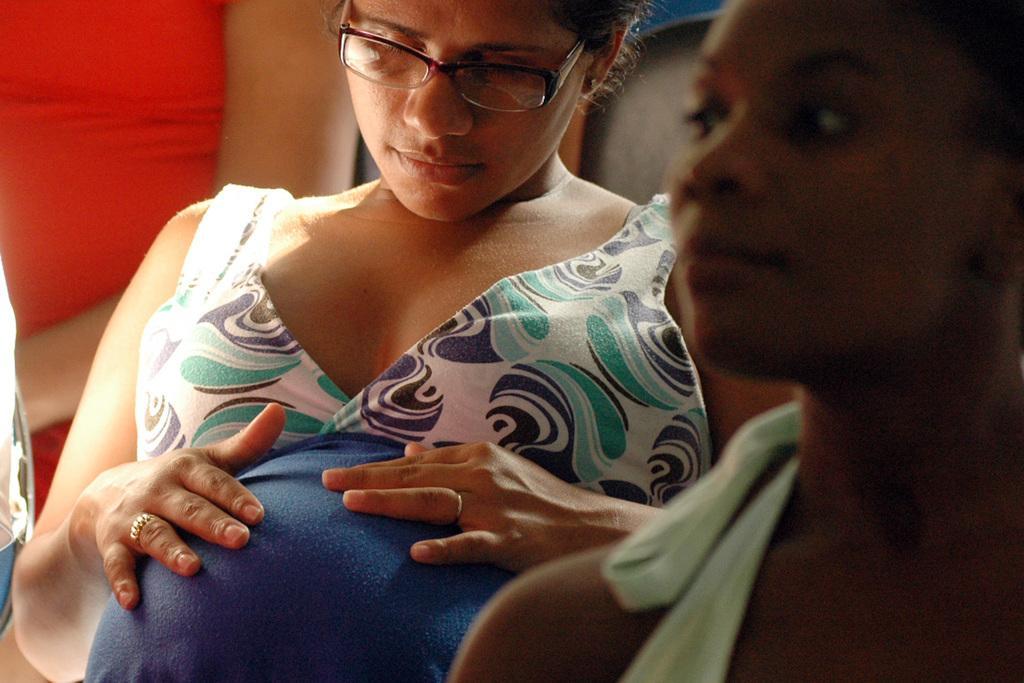Please provide a concise description of this image. In this picture we can see a woman wearing a spectacle and kept her hands on her stomach. We can see a person on the right side. There is an object and a hand of a person is visible on the left side. 